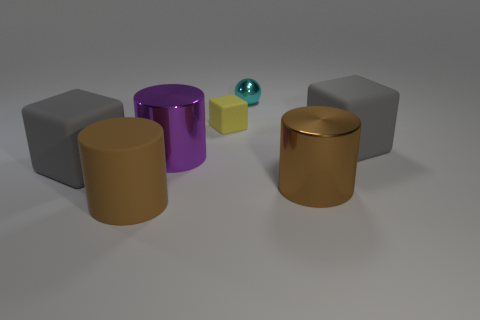Add 2 tiny metal things. How many objects exist? 9 Subtract all spheres. How many objects are left? 6 Subtract 0 blue cylinders. How many objects are left? 7 Subtract all small objects. Subtract all gray matte cubes. How many objects are left? 3 Add 4 small metal things. How many small metal things are left? 5 Add 2 brown cylinders. How many brown cylinders exist? 4 